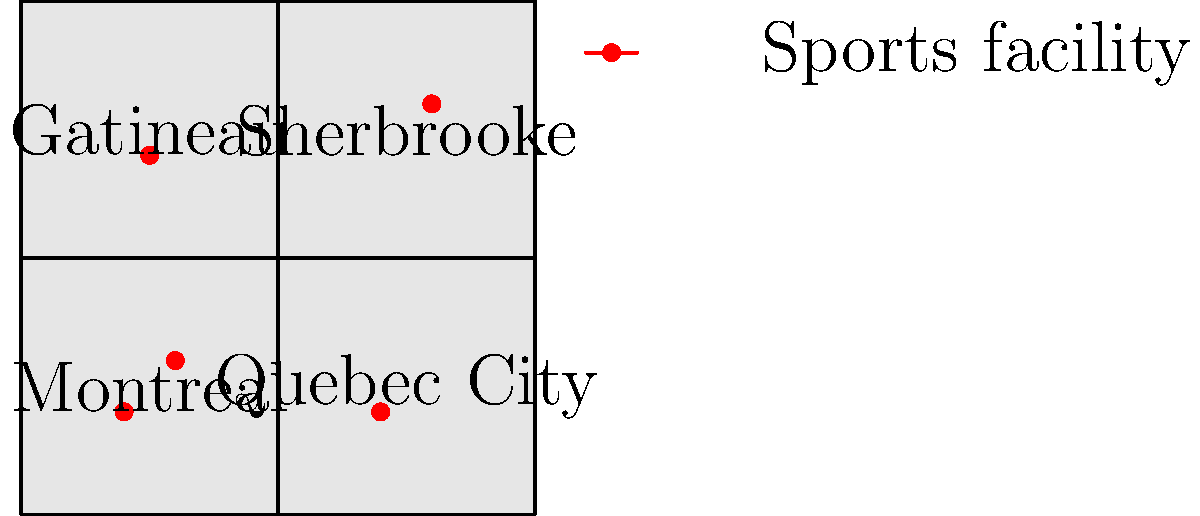Based on the map showing the distribution of sports facilities in four major regions of Quebec, which area appears to have the highest concentration of facilities? To answer this question, we need to analyze the map systematically:

1. The map shows four regions of Quebec: Montreal, Quebec City, Gatineau, and Sherbrooke.

2. Each red dot on the map represents a sports facility.

3. Let's count the number of facilities in each region:
   - Montreal: 2 facilities
   - Quebec City: 1 facility
   - Gatineau: 1 facility
   - Sherbrooke: 1 facility

4. Montreal has the highest number of facilities (2) compared to the other regions, which each have only 1 facility.

5. Additionally, the two facilities in Montreal appear to be closer together than the facilities in other regions, indicating a higher concentration.

Therefore, based on the information provided in the map, Montreal has the highest concentration of sports facilities among the four regions shown.
Answer: Montreal 